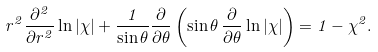Convert formula to latex. <formula><loc_0><loc_0><loc_500><loc_500>r ^ { 2 } \frac { \partial ^ { 2 } } { \partial r ^ { 2 } } \ln | \chi | + \frac { 1 } { \sin \theta } \frac { \partial } { \partial \theta } \left ( \sin \theta \, \frac { \partial } { \partial \theta } \ln | \chi | \right ) = 1 - \chi ^ { 2 } .</formula> 